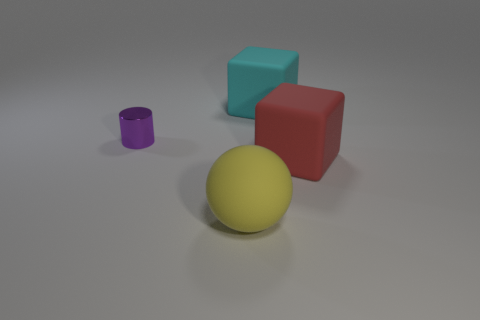Add 1 large yellow spheres. How many objects exist? 5 Add 4 tiny metallic cylinders. How many tiny metallic cylinders are left? 5 Add 2 blue shiny cubes. How many blue shiny cubes exist? 2 Subtract 0 yellow cylinders. How many objects are left? 4 Subtract all tiny things. Subtract all big rubber blocks. How many objects are left? 1 